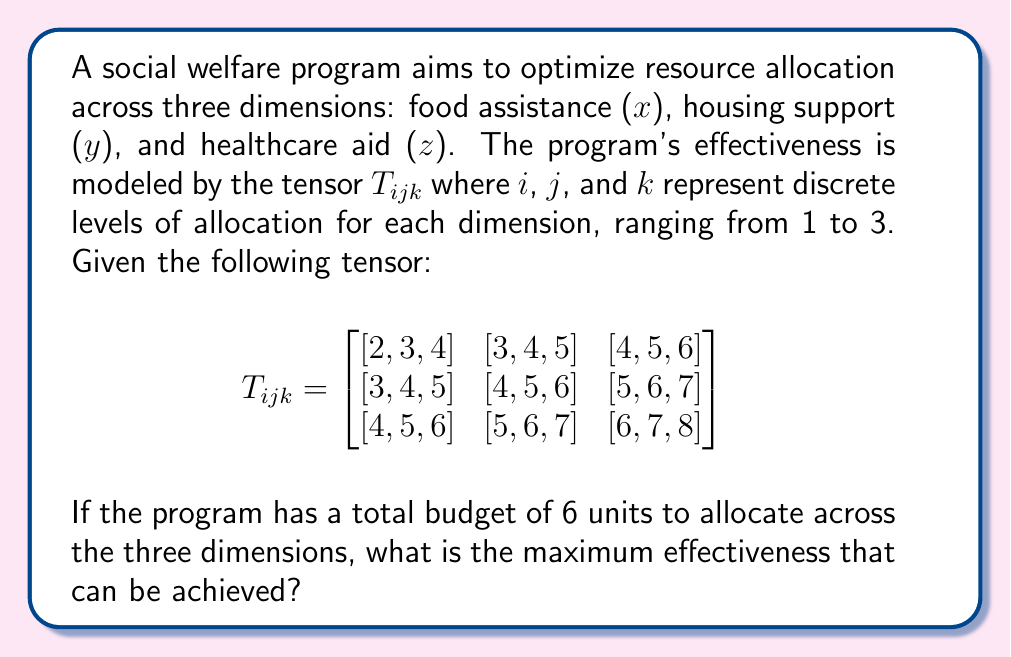Can you solve this math problem? To solve this problem, we need to find the maximum value in the tensor that corresponds to a valid allocation of the 6 budget units. Let's approach this step-by-step:

1) First, we need to understand what the indices represent:
   - $i$ represents the level of food assistance (1, 2, or 3 units)
   - $j$ represents the level of housing support (1, 2, or 3 units)
   - $k$ represents the level of healthcare aid (1, 2, or 3 units)

2) The constraint is that the sum of allocated units must equal 6:

   $x + y + z = 6$, where $x$, $y$, and $z$ are integers from 1 to 3.

3) The possible valid combinations are:
   - (2, 2, 2)
   - (3, 2, 1), (2, 3, 1), (2, 1, 3)
   - (3, 1, 2), (1, 3, 2), (1, 2, 3)

4) Now, let's check the effectiveness value for each combination:
   - (2, 2, 2): $T_{222} = 5$
   - (3, 2, 1): $T_{321} = 5$
   - (2, 3, 1): $T_{231} = 5$
   - (2, 1, 3): $T_{213} = 5$
   - (3, 1, 2): $T_{312} = 5$
   - (1, 3, 2): $T_{132} = 5$
   - (1, 2, 3): $T_{123} = 4$

5) The maximum effectiveness value among these valid allocations is 5.

This result suggests that, given the constraints, multiple allocation strategies can achieve the maximum effectiveness of 5. This information could be valuable for policymakers in understanding the flexibility they have in resource allocation while maintaining optimal effectiveness.
Answer: 5 